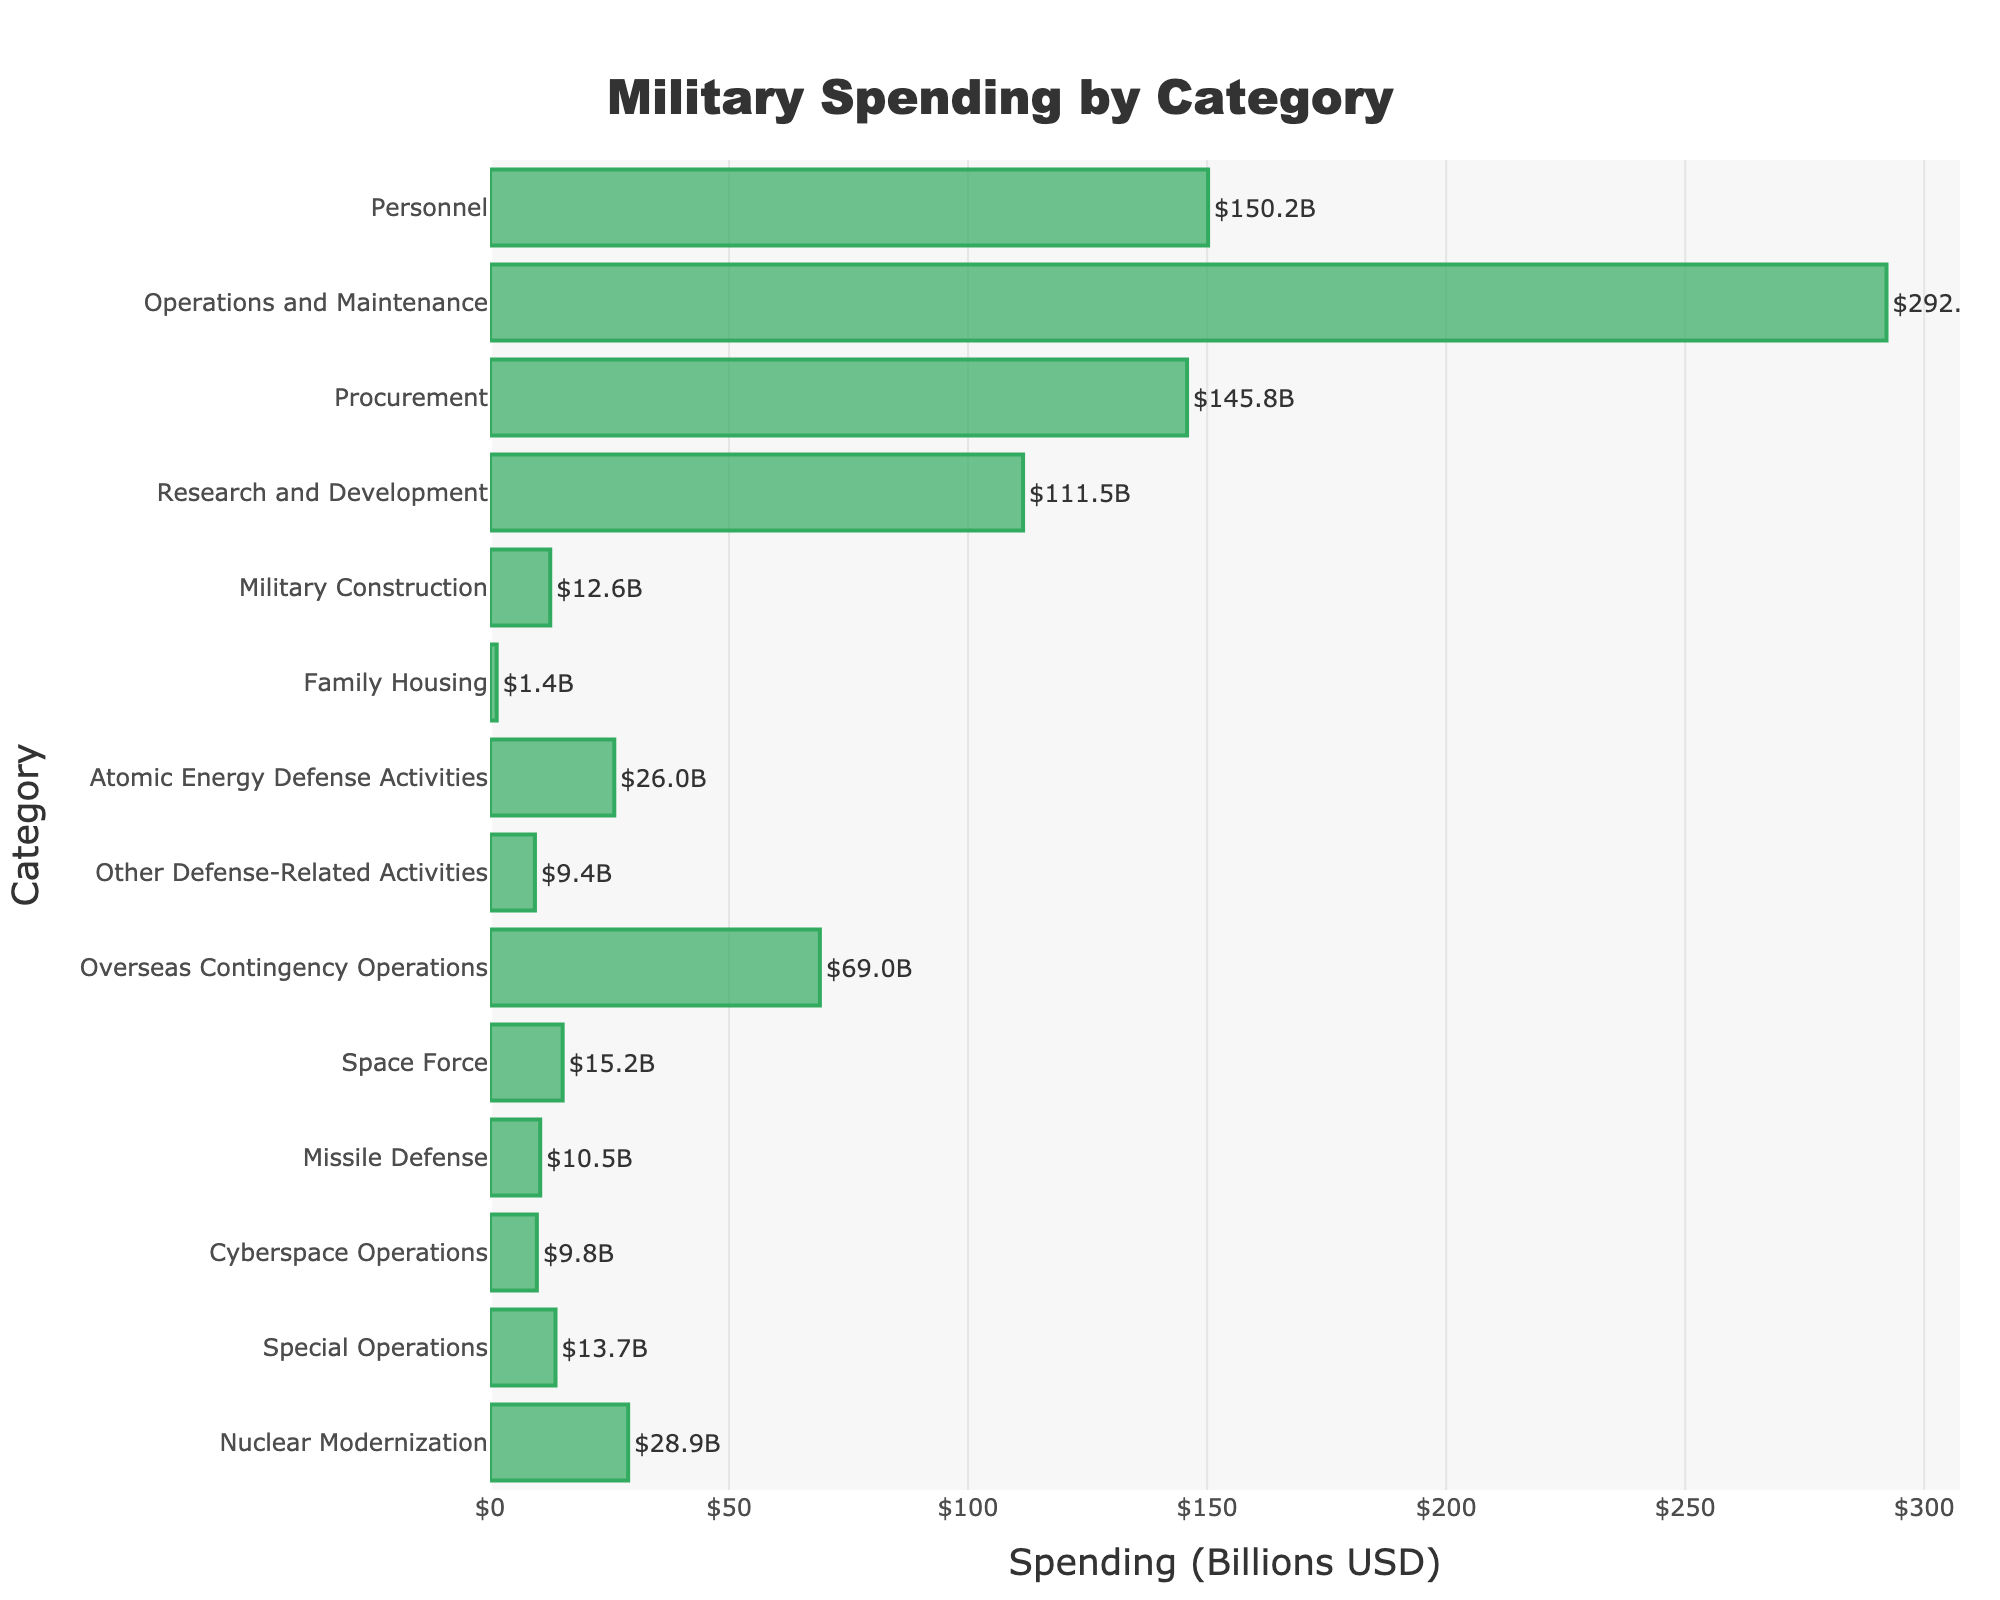Which category has the highest military spending? To determine the category with the highest military spending, locate the bar with the greatest length. In this case, "Operations and Maintenance" has the longest bar.
Answer: Operations and Maintenance What is the combined spending on Special Operations and Cyberspace Operations? Add the spending values for Special Operations ($13.7B) and Cyberspace Operations ($9.8B). $13.7B + $9.8B = $23.5B
Answer: $23.5B How does the spending on Personnel compare to that on Procurement? Compare the spending values: Personnel ($150.2B) and Procurement ($145.8B). Personnel spending is slightly higher.
Answer: Personnel spending is higher What is the difference in spending between Military Construction and Family Housing? Subtract the spending for Family Housing ($1.4B) from Military Construction ($12.6B). $12.6B - $1.4B = $11.2B
Answer: $11.2B Which category has the lowest military spending? Identify the bar with the shortest length, which corresponds to Family Housing ($1.4B).
Answer: Family Housing How much more is spent on Research and Development compared to Missile Defense? Subtract Missile Defense spending ($10.5B) from Research and Development spending ($111.5B). $111.5B - $10.5B = $101.0B
Answer: $101.0B What is the total spending on categories related to nuclear activities? Sum the spending on Atomic Energy Defense Activities ($26.0B) and Nuclear Modernization ($28.9B). $26.0B + $28.9B = $54.9B
Answer: $54.9B What is the average spending across all categories? Sum the spending for all categories and divide by the number of categories (14). Total spending is $896.1B. $896.1B / 14 ≈ $64.0B
Answer: ≈ $64.0B Is the spending on Overseas Contingency Operations more than double that of Military Construction? Compare the two values: Overseas Contingency Operations ($69.0B) and Military Construction ($12.6B). Check if $69.0B is more than twice $12.6B. $12.6B * 2 = $25.2B, and $69.0B > $25.2B.
Answer: Yes 